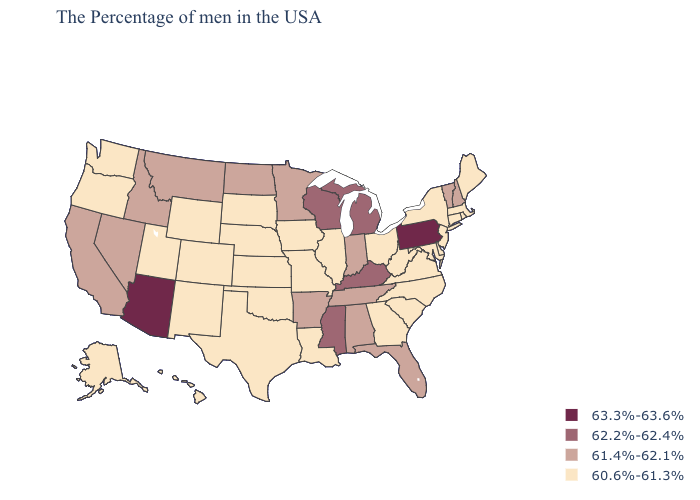Is the legend a continuous bar?
Write a very short answer. No. Name the states that have a value in the range 61.4%-62.1%?
Be succinct. New Hampshire, Vermont, Florida, Indiana, Alabama, Tennessee, Arkansas, Minnesota, North Dakota, Montana, Idaho, Nevada, California. Does Louisiana have the same value as Iowa?
Short answer required. Yes. Among the states that border New Jersey , which have the lowest value?
Write a very short answer. New York, Delaware. Does the first symbol in the legend represent the smallest category?
Concise answer only. No. Which states have the lowest value in the USA?
Give a very brief answer. Maine, Massachusetts, Rhode Island, Connecticut, New York, New Jersey, Delaware, Maryland, Virginia, North Carolina, South Carolina, West Virginia, Ohio, Georgia, Illinois, Louisiana, Missouri, Iowa, Kansas, Nebraska, Oklahoma, Texas, South Dakota, Wyoming, Colorado, New Mexico, Utah, Washington, Oregon, Alaska, Hawaii. Which states have the lowest value in the Northeast?
Write a very short answer. Maine, Massachusetts, Rhode Island, Connecticut, New York, New Jersey. What is the value of New Hampshire?
Answer briefly. 61.4%-62.1%. What is the value of Minnesota?
Write a very short answer. 61.4%-62.1%. Name the states that have a value in the range 63.3%-63.6%?
Write a very short answer. Pennsylvania, Arizona. Name the states that have a value in the range 63.3%-63.6%?
Quick response, please. Pennsylvania, Arizona. Does the first symbol in the legend represent the smallest category?
Give a very brief answer. No. What is the value of Oklahoma?
Answer briefly. 60.6%-61.3%. Among the states that border New Mexico , which have the highest value?
Quick response, please. Arizona. 